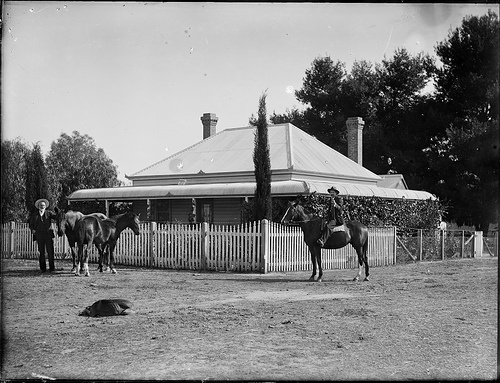Describe the objects in this image and their specific colors. I can see horse in black, gray, darkgray, and lightgray tones, horse in black, gray, darkgray, and lightgray tones, people in black, gray, darkgray, and lightgray tones, horse in black, gray, darkgray, and lightgray tones, and horse in black, gray, darkgray, and lightgray tones in this image. 